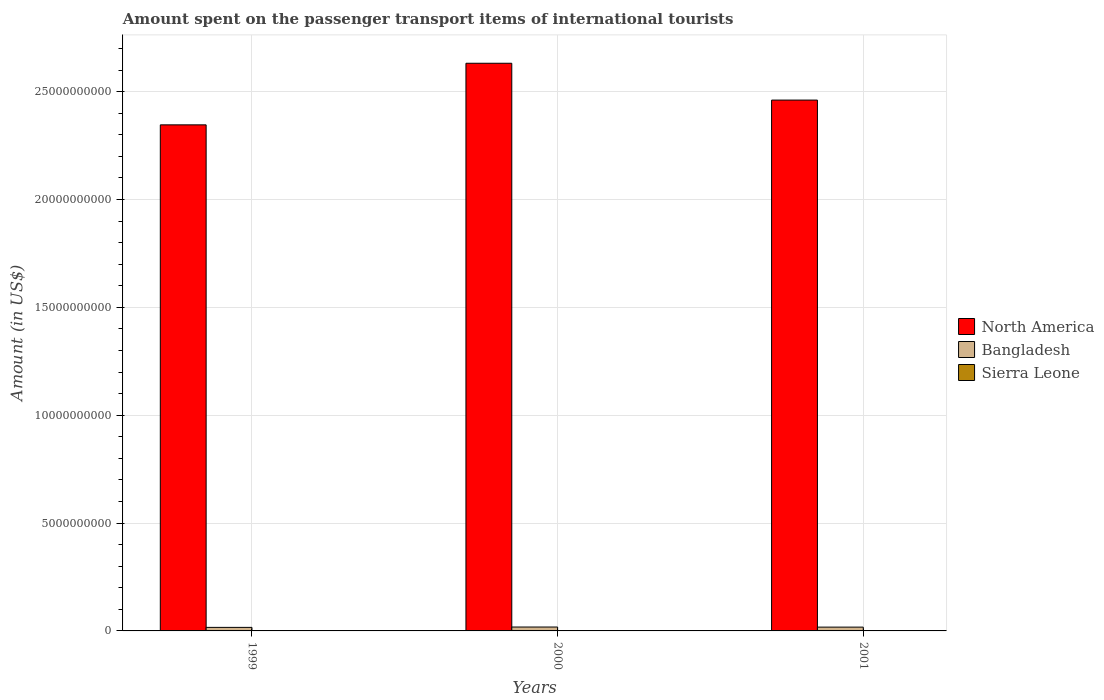How many groups of bars are there?
Provide a succinct answer. 3. Are the number of bars per tick equal to the number of legend labels?
Ensure brevity in your answer.  Yes. Are the number of bars on each tick of the X-axis equal?
Provide a succinct answer. Yes. How many bars are there on the 1st tick from the left?
Ensure brevity in your answer.  3. What is the label of the 2nd group of bars from the left?
Your answer should be very brief. 2000. What is the amount spent on the passenger transport items of international tourists in North America in 1999?
Keep it short and to the point. 2.35e+1. Across all years, what is the maximum amount spent on the passenger transport items of international tourists in Sierra Leone?
Provide a succinct answer. 2.50e+06. Across all years, what is the minimum amount spent on the passenger transport items of international tourists in Sierra Leone?
Offer a very short reply. 2.00e+05. In which year was the amount spent on the passenger transport items of international tourists in Sierra Leone minimum?
Your answer should be very brief. 1999. What is the total amount spent on the passenger transport items of international tourists in North America in the graph?
Ensure brevity in your answer.  7.44e+1. What is the difference between the amount spent on the passenger transport items of international tourists in Bangladesh in 2000 and that in 2001?
Offer a terse response. 5.00e+06. What is the difference between the amount spent on the passenger transport items of international tourists in Sierra Leone in 2000 and the amount spent on the passenger transport items of international tourists in North America in 1999?
Ensure brevity in your answer.  -2.35e+1. What is the average amount spent on the passenger transport items of international tourists in Sierra Leone per year?
Provide a succinct answer. 9.67e+05. In the year 1999, what is the difference between the amount spent on the passenger transport items of international tourists in North America and amount spent on the passenger transport items of international tourists in Sierra Leone?
Ensure brevity in your answer.  2.35e+1. In how many years, is the amount spent on the passenger transport items of international tourists in Sierra Leone greater than 23000000000 US$?
Offer a very short reply. 0. What is the ratio of the amount spent on the passenger transport items of international tourists in North America in 1999 to that in 2001?
Your response must be concise. 0.95. Is the amount spent on the passenger transport items of international tourists in Sierra Leone in 1999 less than that in 2000?
Provide a succinct answer. Yes. What is the difference between the highest and the second highest amount spent on the passenger transport items of international tourists in Bangladesh?
Make the answer very short. 5.00e+06. What is the difference between the highest and the lowest amount spent on the passenger transport items of international tourists in Sierra Leone?
Your answer should be compact. 2.30e+06. What does the 1st bar from the right in 1999 represents?
Offer a very short reply. Sierra Leone. Is it the case that in every year, the sum of the amount spent on the passenger transport items of international tourists in North America and amount spent on the passenger transport items of international tourists in Bangladesh is greater than the amount spent on the passenger transport items of international tourists in Sierra Leone?
Keep it short and to the point. Yes. What is the difference between two consecutive major ticks on the Y-axis?
Make the answer very short. 5.00e+09. Does the graph contain grids?
Your answer should be compact. Yes. Where does the legend appear in the graph?
Offer a very short reply. Center right. What is the title of the graph?
Keep it short and to the point. Amount spent on the passenger transport items of international tourists. What is the label or title of the X-axis?
Provide a short and direct response. Years. What is the Amount (in US$) in North America in 1999?
Offer a terse response. 2.35e+1. What is the Amount (in US$) in Bangladesh in 1999?
Keep it short and to the point. 1.64e+08. What is the Amount (in US$) of Sierra Leone in 1999?
Provide a succinct answer. 2.00e+05. What is the Amount (in US$) in North America in 2000?
Your answer should be very brief. 2.63e+1. What is the Amount (in US$) of Bangladesh in 2000?
Offer a very short reply. 1.81e+08. What is the Amount (in US$) of Sierra Leone in 2000?
Offer a very short reply. 2.50e+06. What is the Amount (in US$) in North America in 2001?
Provide a succinct answer. 2.46e+1. What is the Amount (in US$) of Bangladesh in 2001?
Keep it short and to the point. 1.76e+08. Across all years, what is the maximum Amount (in US$) in North America?
Keep it short and to the point. 2.63e+1. Across all years, what is the maximum Amount (in US$) of Bangladesh?
Offer a terse response. 1.81e+08. Across all years, what is the maximum Amount (in US$) in Sierra Leone?
Ensure brevity in your answer.  2.50e+06. Across all years, what is the minimum Amount (in US$) in North America?
Offer a terse response. 2.35e+1. Across all years, what is the minimum Amount (in US$) of Bangladesh?
Offer a very short reply. 1.64e+08. What is the total Amount (in US$) in North America in the graph?
Give a very brief answer. 7.44e+1. What is the total Amount (in US$) in Bangladesh in the graph?
Provide a succinct answer. 5.21e+08. What is the total Amount (in US$) in Sierra Leone in the graph?
Your answer should be compact. 2.90e+06. What is the difference between the Amount (in US$) in North America in 1999 and that in 2000?
Your response must be concise. -2.86e+09. What is the difference between the Amount (in US$) of Bangladesh in 1999 and that in 2000?
Your answer should be compact. -1.70e+07. What is the difference between the Amount (in US$) of Sierra Leone in 1999 and that in 2000?
Your response must be concise. -2.30e+06. What is the difference between the Amount (in US$) in North America in 1999 and that in 2001?
Provide a succinct answer. -1.15e+09. What is the difference between the Amount (in US$) of Bangladesh in 1999 and that in 2001?
Ensure brevity in your answer.  -1.20e+07. What is the difference between the Amount (in US$) of Sierra Leone in 1999 and that in 2001?
Provide a short and direct response. 0. What is the difference between the Amount (in US$) of North America in 2000 and that in 2001?
Ensure brevity in your answer.  1.71e+09. What is the difference between the Amount (in US$) of Sierra Leone in 2000 and that in 2001?
Keep it short and to the point. 2.30e+06. What is the difference between the Amount (in US$) of North America in 1999 and the Amount (in US$) of Bangladesh in 2000?
Give a very brief answer. 2.33e+1. What is the difference between the Amount (in US$) of North America in 1999 and the Amount (in US$) of Sierra Leone in 2000?
Give a very brief answer. 2.35e+1. What is the difference between the Amount (in US$) of Bangladesh in 1999 and the Amount (in US$) of Sierra Leone in 2000?
Keep it short and to the point. 1.62e+08. What is the difference between the Amount (in US$) of North America in 1999 and the Amount (in US$) of Bangladesh in 2001?
Offer a terse response. 2.33e+1. What is the difference between the Amount (in US$) of North America in 1999 and the Amount (in US$) of Sierra Leone in 2001?
Your response must be concise. 2.35e+1. What is the difference between the Amount (in US$) in Bangladesh in 1999 and the Amount (in US$) in Sierra Leone in 2001?
Your response must be concise. 1.64e+08. What is the difference between the Amount (in US$) in North America in 2000 and the Amount (in US$) in Bangladesh in 2001?
Keep it short and to the point. 2.61e+1. What is the difference between the Amount (in US$) in North America in 2000 and the Amount (in US$) in Sierra Leone in 2001?
Offer a very short reply. 2.63e+1. What is the difference between the Amount (in US$) in Bangladesh in 2000 and the Amount (in US$) in Sierra Leone in 2001?
Offer a terse response. 1.81e+08. What is the average Amount (in US$) of North America per year?
Your answer should be very brief. 2.48e+1. What is the average Amount (in US$) in Bangladesh per year?
Provide a short and direct response. 1.74e+08. What is the average Amount (in US$) in Sierra Leone per year?
Your answer should be very brief. 9.67e+05. In the year 1999, what is the difference between the Amount (in US$) in North America and Amount (in US$) in Bangladesh?
Your answer should be very brief. 2.33e+1. In the year 1999, what is the difference between the Amount (in US$) in North America and Amount (in US$) in Sierra Leone?
Ensure brevity in your answer.  2.35e+1. In the year 1999, what is the difference between the Amount (in US$) of Bangladesh and Amount (in US$) of Sierra Leone?
Ensure brevity in your answer.  1.64e+08. In the year 2000, what is the difference between the Amount (in US$) of North America and Amount (in US$) of Bangladesh?
Provide a succinct answer. 2.61e+1. In the year 2000, what is the difference between the Amount (in US$) of North America and Amount (in US$) of Sierra Leone?
Provide a short and direct response. 2.63e+1. In the year 2000, what is the difference between the Amount (in US$) in Bangladesh and Amount (in US$) in Sierra Leone?
Your answer should be very brief. 1.78e+08. In the year 2001, what is the difference between the Amount (in US$) in North America and Amount (in US$) in Bangladesh?
Ensure brevity in your answer.  2.44e+1. In the year 2001, what is the difference between the Amount (in US$) of North America and Amount (in US$) of Sierra Leone?
Provide a short and direct response. 2.46e+1. In the year 2001, what is the difference between the Amount (in US$) in Bangladesh and Amount (in US$) in Sierra Leone?
Keep it short and to the point. 1.76e+08. What is the ratio of the Amount (in US$) of North America in 1999 to that in 2000?
Provide a short and direct response. 0.89. What is the ratio of the Amount (in US$) in Bangladesh in 1999 to that in 2000?
Your answer should be compact. 0.91. What is the ratio of the Amount (in US$) in North America in 1999 to that in 2001?
Give a very brief answer. 0.95. What is the ratio of the Amount (in US$) in Bangladesh in 1999 to that in 2001?
Provide a succinct answer. 0.93. What is the ratio of the Amount (in US$) in North America in 2000 to that in 2001?
Give a very brief answer. 1.07. What is the ratio of the Amount (in US$) in Bangladesh in 2000 to that in 2001?
Provide a succinct answer. 1.03. What is the difference between the highest and the second highest Amount (in US$) in North America?
Make the answer very short. 1.71e+09. What is the difference between the highest and the second highest Amount (in US$) in Sierra Leone?
Your answer should be very brief. 2.30e+06. What is the difference between the highest and the lowest Amount (in US$) in North America?
Your response must be concise. 2.86e+09. What is the difference between the highest and the lowest Amount (in US$) of Bangladesh?
Your response must be concise. 1.70e+07. What is the difference between the highest and the lowest Amount (in US$) in Sierra Leone?
Your answer should be compact. 2.30e+06. 